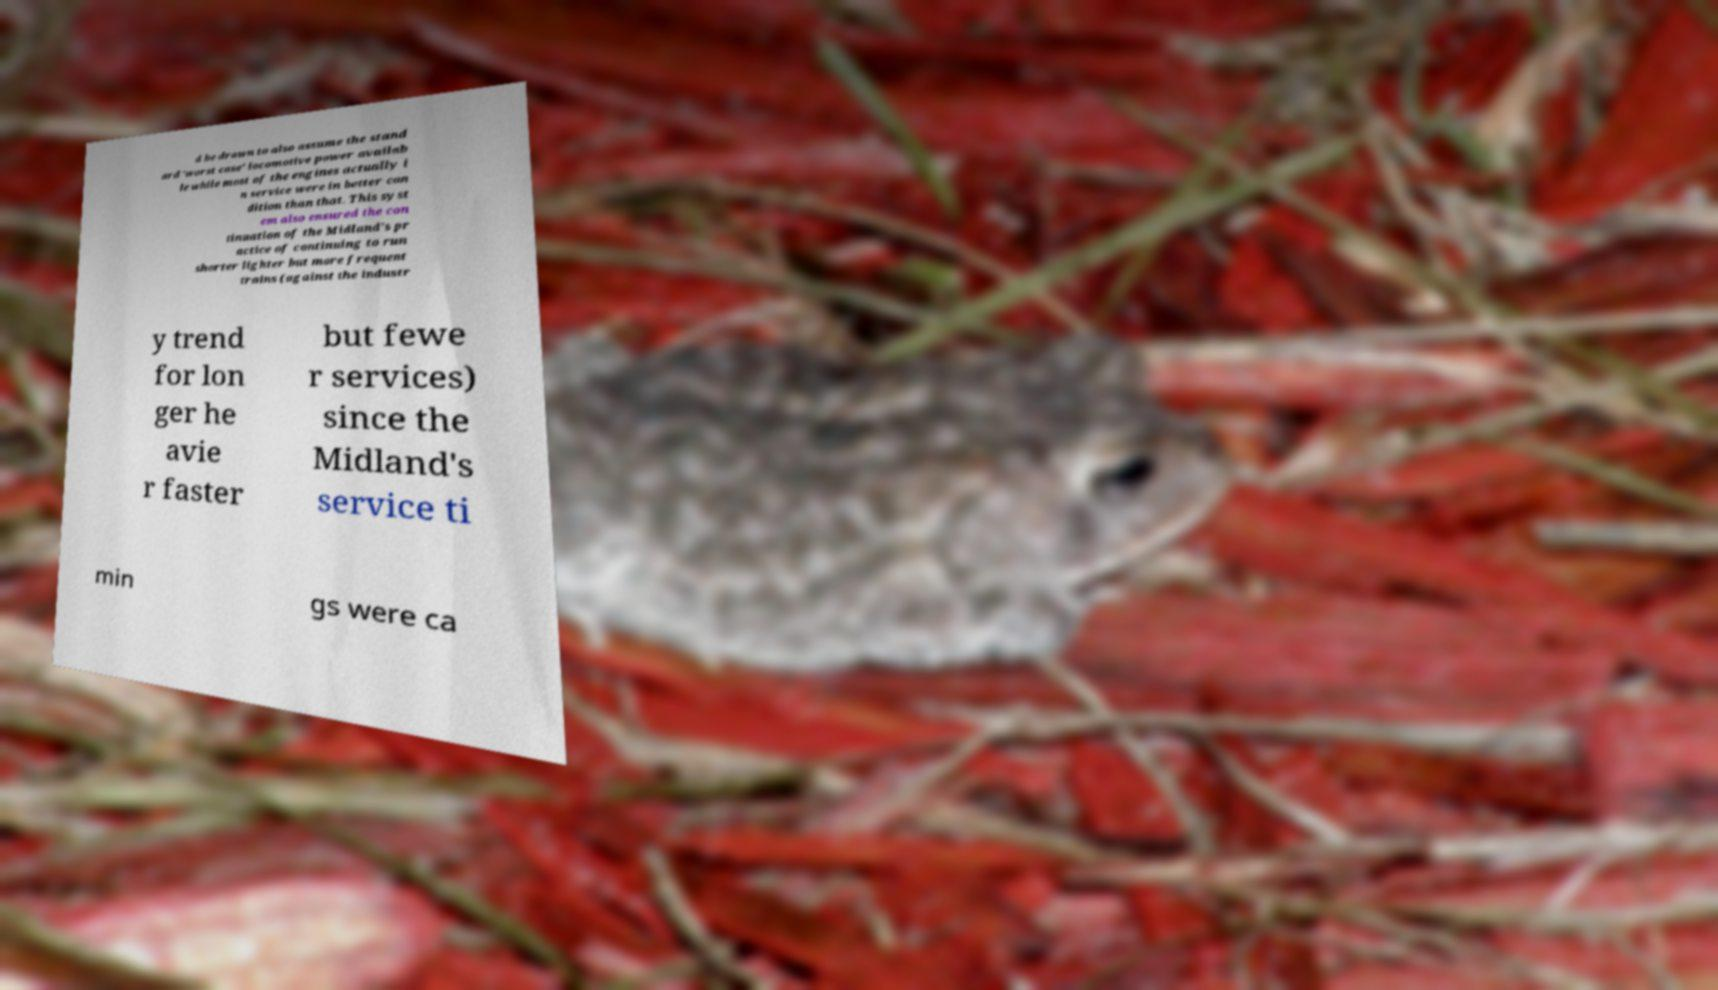Please identify and transcribe the text found in this image. d be drawn to also assume the stand ard 'worst case' locomotive power availab le while most of the engines actually i n service were in better con dition than that. This syst em also ensured the con tinuation of the Midland's pr actice of continuing to run shorter lighter but more frequent trains (against the industr y trend for lon ger he avie r faster but fewe r services) since the Midland's service ti min gs were ca 